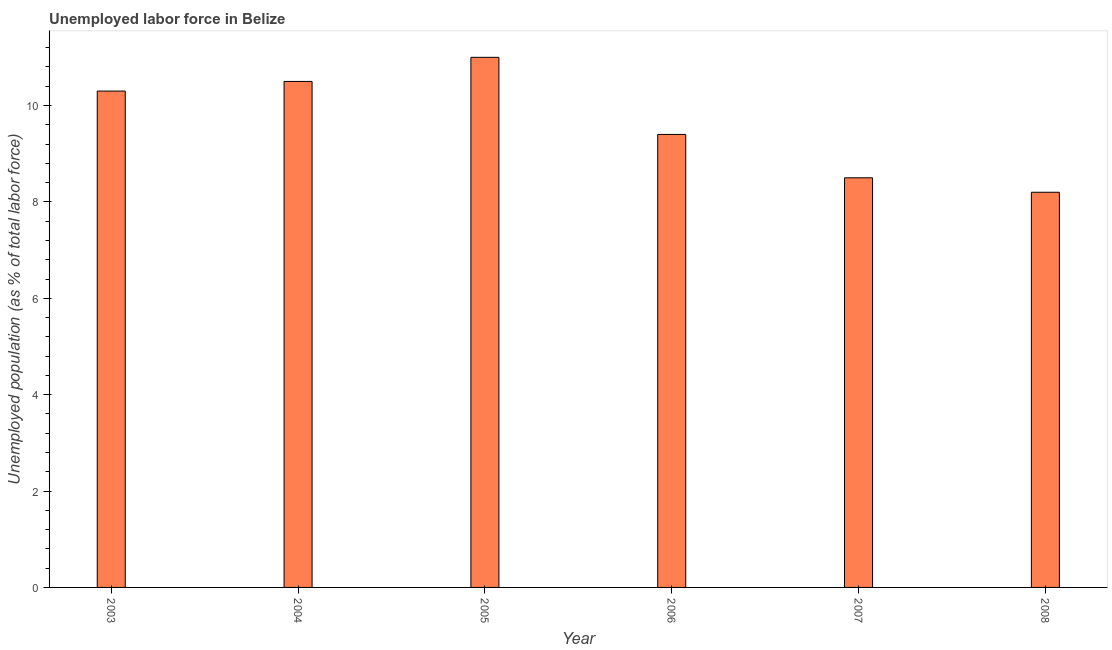What is the title of the graph?
Offer a very short reply. Unemployed labor force in Belize. What is the label or title of the X-axis?
Provide a short and direct response. Year. What is the label or title of the Y-axis?
Make the answer very short. Unemployed population (as % of total labor force). What is the total unemployed population in 2004?
Your answer should be compact. 10.5. Across all years, what is the minimum total unemployed population?
Your answer should be very brief. 8.2. In which year was the total unemployed population maximum?
Your response must be concise. 2005. What is the sum of the total unemployed population?
Your answer should be very brief. 57.9. What is the average total unemployed population per year?
Ensure brevity in your answer.  9.65. What is the median total unemployed population?
Offer a terse response. 9.85. What is the ratio of the total unemployed population in 2003 to that in 2005?
Offer a very short reply. 0.94. What is the difference between the highest and the second highest total unemployed population?
Offer a very short reply. 0.5. What is the difference between the highest and the lowest total unemployed population?
Give a very brief answer. 2.8. In how many years, is the total unemployed population greater than the average total unemployed population taken over all years?
Your answer should be compact. 3. How many bars are there?
Your answer should be very brief. 6. Are all the bars in the graph horizontal?
Make the answer very short. No. What is the difference between two consecutive major ticks on the Y-axis?
Make the answer very short. 2. What is the Unemployed population (as % of total labor force) of 2003?
Ensure brevity in your answer.  10.3. What is the Unemployed population (as % of total labor force) of 2006?
Ensure brevity in your answer.  9.4. What is the Unemployed population (as % of total labor force) of 2008?
Provide a succinct answer. 8.2. What is the difference between the Unemployed population (as % of total labor force) in 2003 and 2004?
Ensure brevity in your answer.  -0.2. What is the difference between the Unemployed population (as % of total labor force) in 2003 and 2005?
Keep it short and to the point. -0.7. What is the difference between the Unemployed population (as % of total labor force) in 2003 and 2007?
Offer a terse response. 1.8. What is the difference between the Unemployed population (as % of total labor force) in 2004 and 2006?
Ensure brevity in your answer.  1.1. What is the difference between the Unemployed population (as % of total labor force) in 2005 and 2008?
Your answer should be compact. 2.8. What is the difference between the Unemployed population (as % of total labor force) in 2007 and 2008?
Your answer should be very brief. 0.3. What is the ratio of the Unemployed population (as % of total labor force) in 2003 to that in 2004?
Your answer should be compact. 0.98. What is the ratio of the Unemployed population (as % of total labor force) in 2003 to that in 2005?
Ensure brevity in your answer.  0.94. What is the ratio of the Unemployed population (as % of total labor force) in 2003 to that in 2006?
Your answer should be compact. 1.1. What is the ratio of the Unemployed population (as % of total labor force) in 2003 to that in 2007?
Offer a very short reply. 1.21. What is the ratio of the Unemployed population (as % of total labor force) in 2003 to that in 2008?
Your answer should be very brief. 1.26. What is the ratio of the Unemployed population (as % of total labor force) in 2004 to that in 2005?
Your response must be concise. 0.95. What is the ratio of the Unemployed population (as % of total labor force) in 2004 to that in 2006?
Provide a short and direct response. 1.12. What is the ratio of the Unemployed population (as % of total labor force) in 2004 to that in 2007?
Provide a succinct answer. 1.24. What is the ratio of the Unemployed population (as % of total labor force) in 2004 to that in 2008?
Make the answer very short. 1.28. What is the ratio of the Unemployed population (as % of total labor force) in 2005 to that in 2006?
Your answer should be compact. 1.17. What is the ratio of the Unemployed population (as % of total labor force) in 2005 to that in 2007?
Your answer should be compact. 1.29. What is the ratio of the Unemployed population (as % of total labor force) in 2005 to that in 2008?
Ensure brevity in your answer.  1.34. What is the ratio of the Unemployed population (as % of total labor force) in 2006 to that in 2007?
Your answer should be very brief. 1.11. What is the ratio of the Unemployed population (as % of total labor force) in 2006 to that in 2008?
Keep it short and to the point. 1.15. 